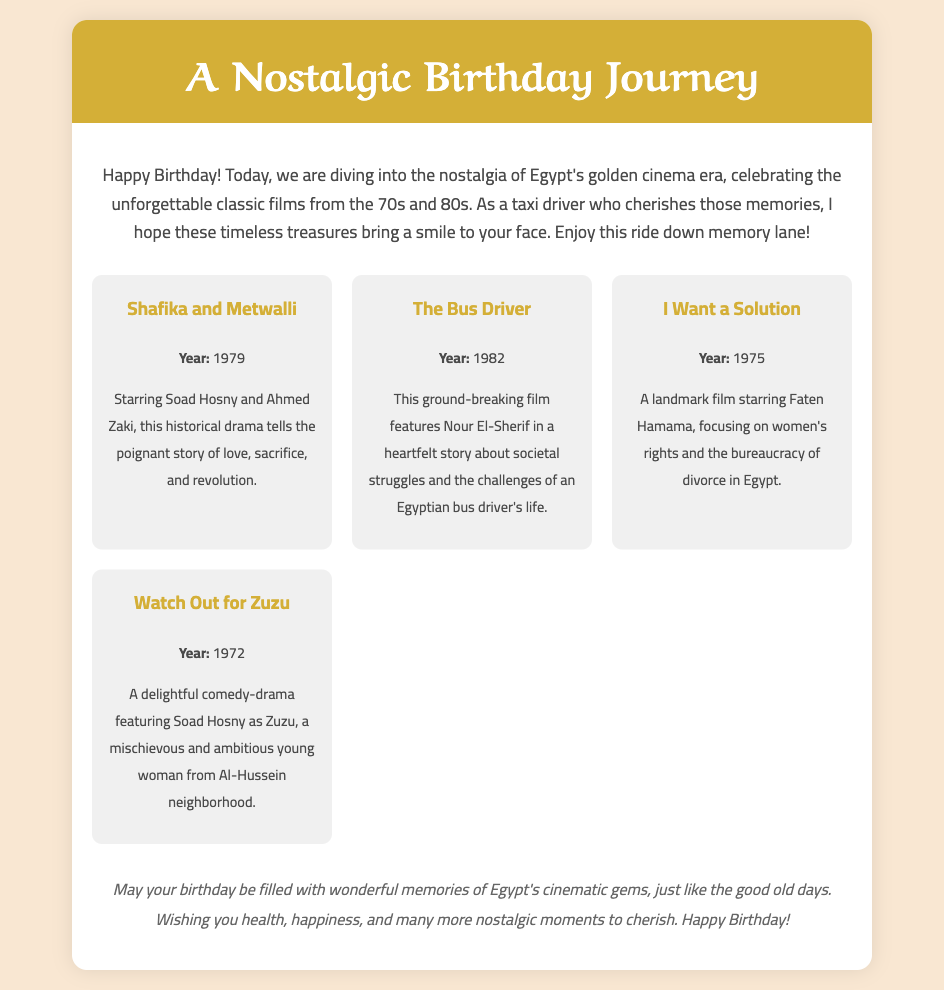What is the title of the greeting card? The title is prominently displayed in the header section of the card.
Answer: A Nostalgic Birthday Journey What year was "Shafika and Metwalli" released? The release year is provided in the poster section of the card.
Answer: 1979 Who stars in "I Want a Solution"? The starring actor is mentioned in the description of the film.
Answer: Faten Hamama How many films are featured in the card? The number of films can be counted in the posters section.
Answer: Four What genre is "The Bus Driver"? The genre can be inferred from the description provided in the poster.
Answer: Heartfelt story What does the card wish for the birthday person? The wish is summarized at the end of the message.
Answer: Health, happiness, and nostalgic moments What decoration style is used in the card's design? The design style is evident from the overall aesthetic and color scheme described.
Answer: Nostalgic What type of film is "Watch Out for Zuzu"? The type is inferred from the sentiments expressed in the movie's description.
Answer: Comedy-drama What is the primary theme of "I Want a Solution"? The theme of the film is highlighted in its description.
Answer: Women's rights 